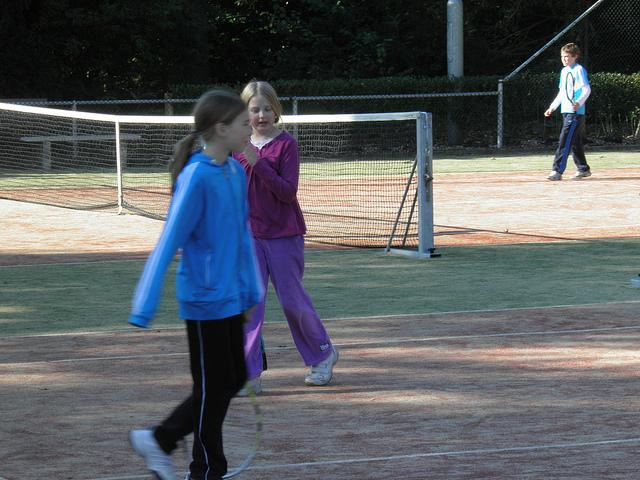What hair style does the girl in blue have?

Choices:
A) pig tails
B) mullet
C) pony tail
D) crew cut pony tail 